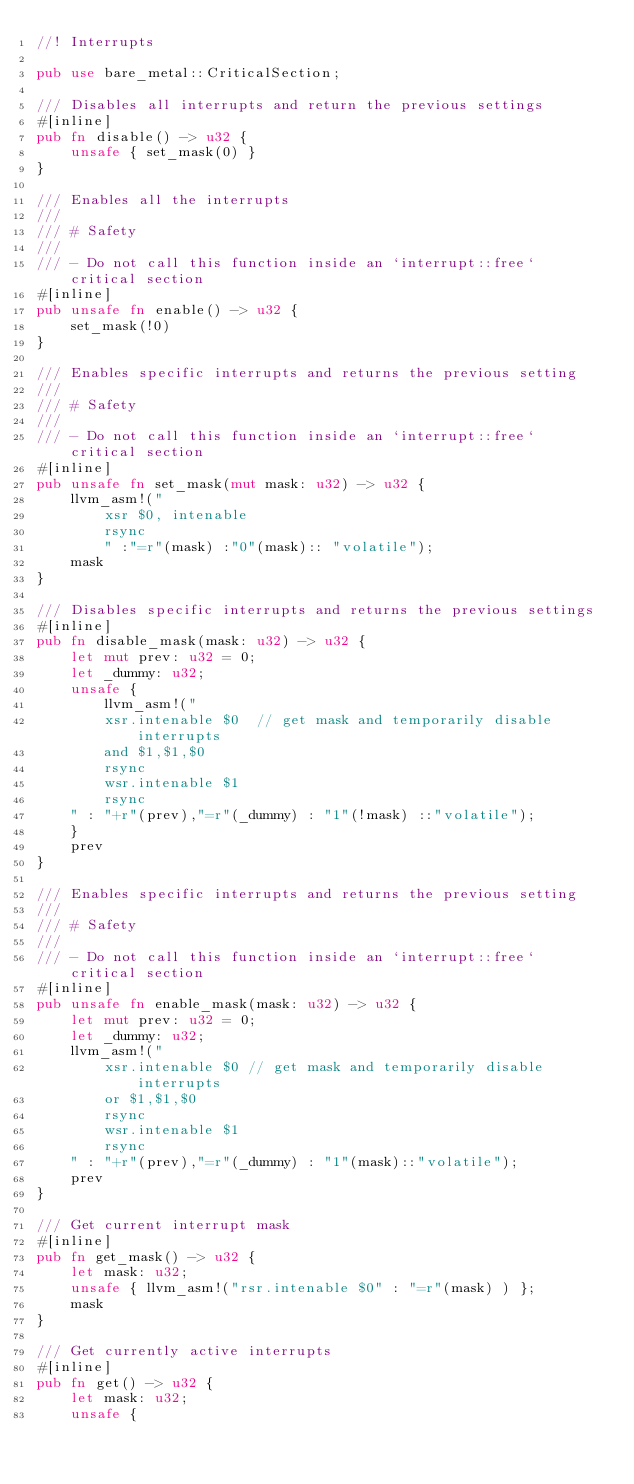Convert code to text. <code><loc_0><loc_0><loc_500><loc_500><_Rust_>//! Interrupts

pub use bare_metal::CriticalSection;

/// Disables all interrupts and return the previous settings
#[inline]
pub fn disable() -> u32 {
    unsafe { set_mask(0) }
}

/// Enables all the interrupts
///
/// # Safety
///
/// - Do not call this function inside an `interrupt::free` critical section
#[inline]
pub unsafe fn enable() -> u32 {
    set_mask(!0)
}

/// Enables specific interrupts and returns the previous setting
///
/// # Safety
///
/// - Do not call this function inside an `interrupt::free` critical section
#[inline]
pub unsafe fn set_mask(mut mask: u32) -> u32 {
    llvm_asm!("
        xsr $0, intenable
        rsync
        " :"=r"(mask) :"0"(mask):: "volatile");
    mask
}

/// Disables specific interrupts and returns the previous settings
#[inline]
pub fn disable_mask(mask: u32) -> u32 {
    let mut prev: u32 = 0;
    let _dummy: u32;
    unsafe {
        llvm_asm!("
        xsr.intenable $0  // get mask and temporarily disable interrupts 
        and $1,$1,$0
        rsync
        wsr.intenable $1
        rsync
    " : "+r"(prev),"=r"(_dummy) : "1"(!mask) ::"volatile");
    }
    prev
}

/// Enables specific interrupts and returns the previous setting
///
/// # Safety
///
/// - Do not call this function inside an `interrupt::free` critical section
#[inline]
pub unsafe fn enable_mask(mask: u32) -> u32 {
    let mut prev: u32 = 0;
    let _dummy: u32;
    llvm_asm!("
        xsr.intenable $0 // get mask and temporarily disable interrupts
        or $1,$1,$0
        rsync
        wsr.intenable $1
        rsync
    " : "+r"(prev),"=r"(_dummy) : "1"(mask)::"volatile");
    prev
}

/// Get current interrupt mask
#[inline]
pub fn get_mask() -> u32 {
    let mask: u32;
    unsafe { llvm_asm!("rsr.intenable $0" : "=r"(mask) ) };
    mask
}

/// Get currently active interrupts
#[inline]
pub fn get() -> u32 {
    let mask: u32;
    unsafe {</code> 